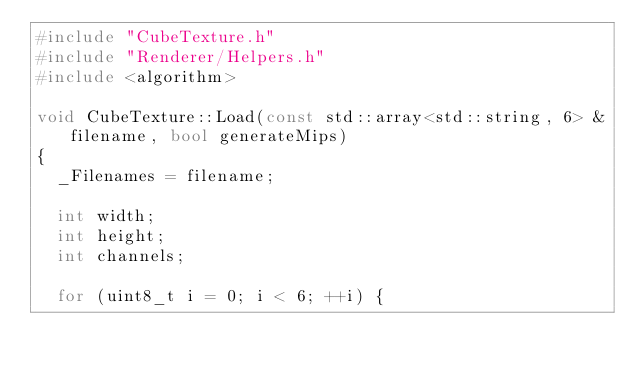<code> <loc_0><loc_0><loc_500><loc_500><_C++_>#include "CubeTexture.h"
#include "Renderer/Helpers.h"
#include <algorithm>

void CubeTexture::Load(const std::array<std::string, 6> &filename, bool generateMips)
{
	_Filenames = filename;

	int width;
	int height;
	int channels;

	for (uint8_t i = 0; i < 6; ++i) {</code> 